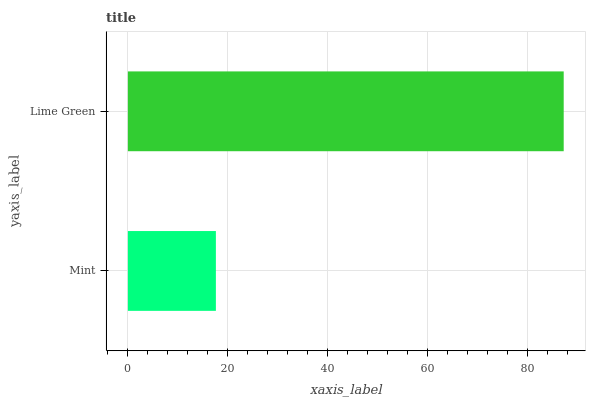Is Mint the minimum?
Answer yes or no. Yes. Is Lime Green the maximum?
Answer yes or no. Yes. Is Lime Green the minimum?
Answer yes or no. No. Is Lime Green greater than Mint?
Answer yes or no. Yes. Is Mint less than Lime Green?
Answer yes or no. Yes. Is Mint greater than Lime Green?
Answer yes or no. No. Is Lime Green less than Mint?
Answer yes or no. No. Is Lime Green the high median?
Answer yes or no. Yes. Is Mint the low median?
Answer yes or no. Yes. Is Mint the high median?
Answer yes or no. No. Is Lime Green the low median?
Answer yes or no. No. 